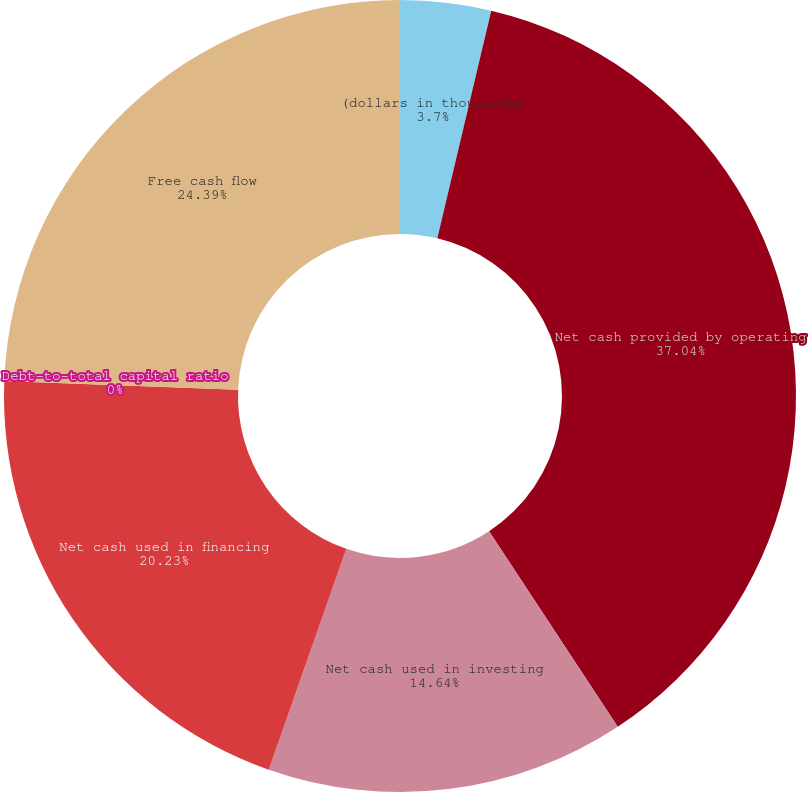Convert chart to OTSL. <chart><loc_0><loc_0><loc_500><loc_500><pie_chart><fcel>(dollars in thousands)<fcel>Net cash provided by operating<fcel>Net cash used in investing<fcel>Net cash used in financing<fcel>Debt-to-total capital ratio<fcel>Free cash flow<nl><fcel>3.7%<fcel>37.03%<fcel>14.64%<fcel>20.23%<fcel>0.0%<fcel>24.39%<nl></chart> 